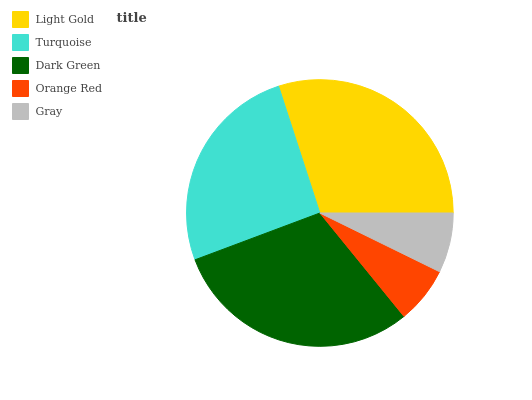Is Orange Red the minimum?
Answer yes or no. Yes. Is Dark Green the maximum?
Answer yes or no. Yes. Is Turquoise the minimum?
Answer yes or no. No. Is Turquoise the maximum?
Answer yes or no. No. Is Light Gold greater than Turquoise?
Answer yes or no. Yes. Is Turquoise less than Light Gold?
Answer yes or no. Yes. Is Turquoise greater than Light Gold?
Answer yes or no. No. Is Light Gold less than Turquoise?
Answer yes or no. No. Is Turquoise the high median?
Answer yes or no. Yes. Is Turquoise the low median?
Answer yes or no. Yes. Is Orange Red the high median?
Answer yes or no. No. Is Gray the low median?
Answer yes or no. No. 